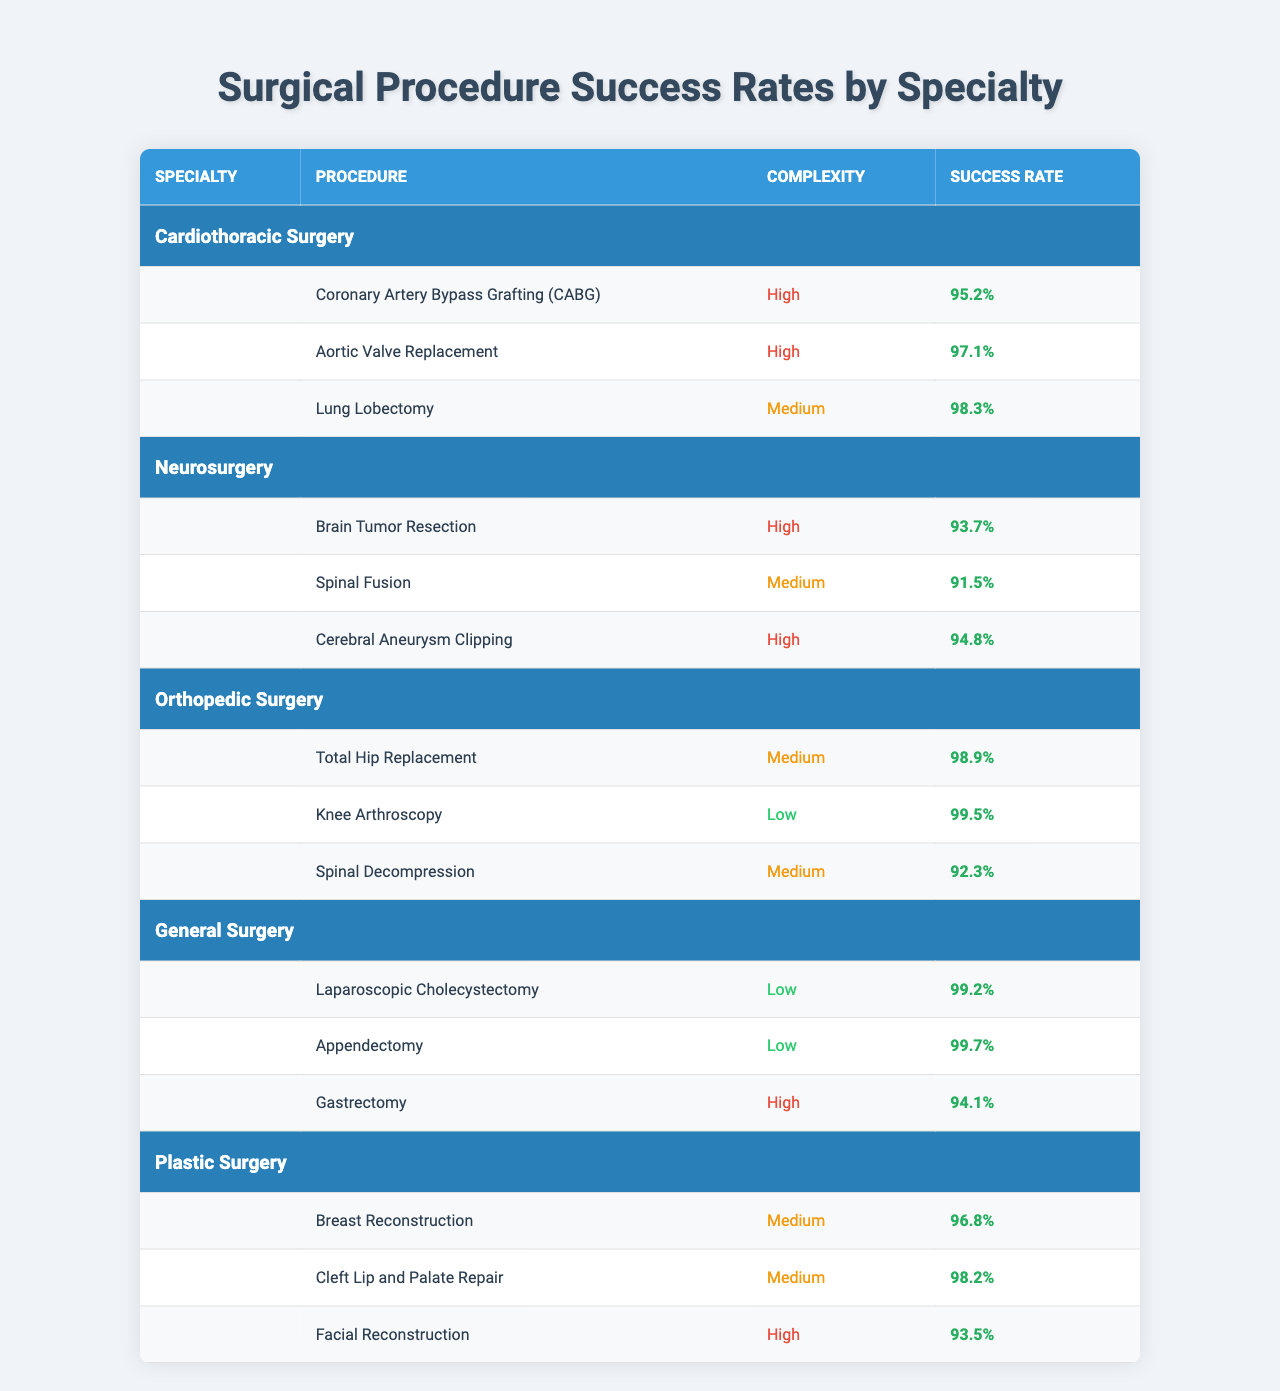What is the success rate of Aortic Valve Replacement in Cardiothoracic Surgery? The table shows that the success rate for Aortic Valve Replacement under the Cardiothoracic Surgery specialty is 97.1%.
Answer: 97.1% Which surgical specialty has the lowest success rate for high complexity procedures? Reviewing the high complexity procedures, Neurosurgery has the lowest success rate with Brain Tumor Resection at 93.7%.
Answer: Neurosurgery How many medium complexity procedures have success rates above 95%? In the table, three medium complexity procedures have success rates above 95%: Lung Lobectomy (98.3%), Total Hip Replacement (98.9%), and Cleft Lip and Palate Repair (98.2%). Count them gives a total of 3.
Answer: 3 Is the success rate of Knee Arthroscopy higher than that of Spinal Decompression? The success rate for Knee Arthroscopy is 99.5%, while for Spinal Decompression it is 92.3%. Since 99.5% is higher than 92.3%, the statement is true.
Answer: Yes What are the success rates for all high complexity procedures combined? The success rates are 95.2% for CABG, 97.1% for Aortic Valve Replacement, 93.7% for Brain Tumor Resection, 94.8% for Cerebral Aneurysm Clipping, and 94.1% for Gastrectomy. Adding these gives a total of 95.2 + 97.1 + 93.7 + 94.8 + 94.1 = 474.9%. Dividing by the number of procedures (5) gives an average success rate of 94.98%.
Answer: 94.98% Which procedure in Plastic Surgery has the highest success rate? According to the table, the highest success rate in Plastic Surgery is for Cleft Lip and Palate Repair at 98.2%.
Answer: Cleft Lip and Palate Repair How does the success rate of Appendectomy compare to that of Gastrectomy? The success rate of Appendectomy is 99.7%, while the success rate of Gastrectomy is 94.1%. Since 99.7% is higher than 94.1%, Appendectomy has a better success rate.
Answer: Appendectomy is higher What is the average success rate for all low complexity procedures? The low complexity procedures listed are Knee Arthroscopy with a success rate of 99.5%, Laparoscopic Cholecystectomy at 99.2%, and Appendectomy at 99.7%. Summing these gives 99.5 + 99.2 + 99.7 = 298.4%. Dividing this by 3 (the number of procedures) results in an average of 99.47%.
Answer: 99.47% Are there any specialties with no low complexity procedures? Since the table lists specialty procedures, we see that both Orthopedic Surgery and General Surgery include low complexity procedures (Knee Arthroscopy, Laparoscopic Cholecystectomy, and Appendectomy, respectively). Therefore, there are no specialties with exclusively high complexity procedures.
Answer: No 